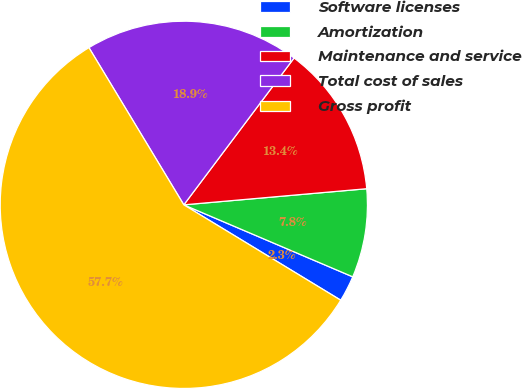Convert chart to OTSL. <chart><loc_0><loc_0><loc_500><loc_500><pie_chart><fcel>Software licenses<fcel>Amortization<fcel>Maintenance and service<fcel>Total cost of sales<fcel>Gross profit<nl><fcel>2.28%<fcel>7.81%<fcel>13.35%<fcel>18.89%<fcel>57.66%<nl></chart> 